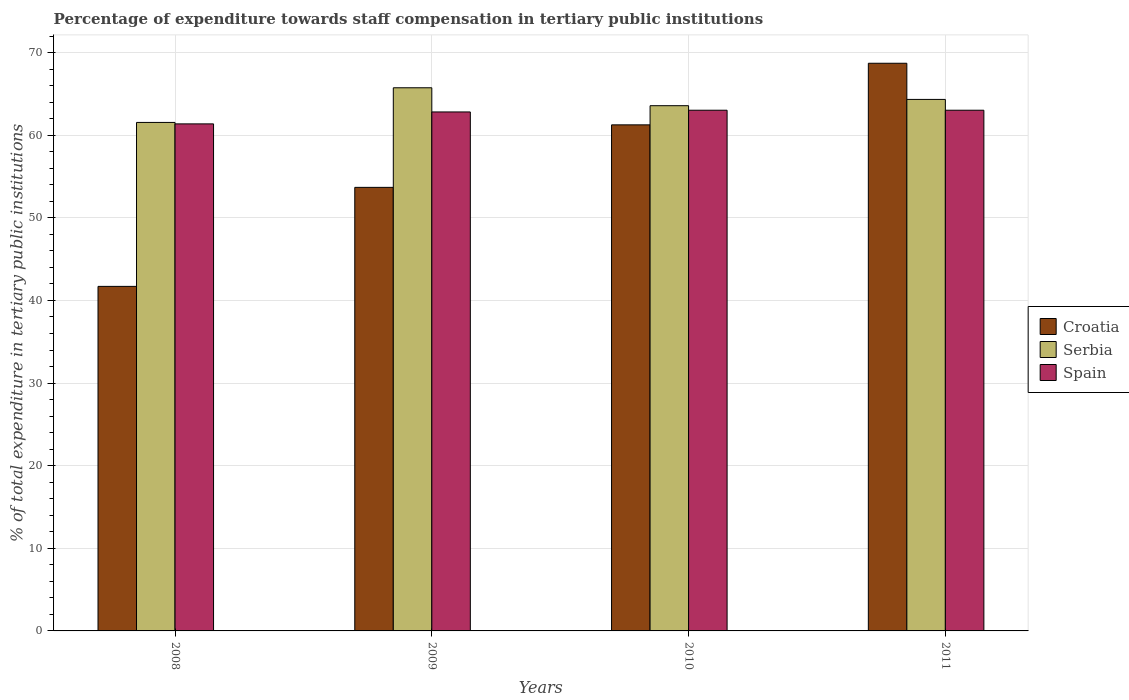Are the number of bars per tick equal to the number of legend labels?
Provide a succinct answer. Yes. Are the number of bars on each tick of the X-axis equal?
Offer a terse response. Yes. How many bars are there on the 1st tick from the left?
Make the answer very short. 3. How many bars are there on the 2nd tick from the right?
Make the answer very short. 3. What is the label of the 2nd group of bars from the left?
Offer a very short reply. 2009. In how many cases, is the number of bars for a given year not equal to the number of legend labels?
Provide a short and direct response. 0. What is the percentage of expenditure towards staff compensation in Spain in 2009?
Give a very brief answer. 62.82. Across all years, what is the maximum percentage of expenditure towards staff compensation in Croatia?
Keep it short and to the point. 68.71. Across all years, what is the minimum percentage of expenditure towards staff compensation in Serbia?
Ensure brevity in your answer.  61.55. In which year was the percentage of expenditure towards staff compensation in Spain maximum?
Provide a succinct answer. 2010. What is the total percentage of expenditure towards staff compensation in Serbia in the graph?
Ensure brevity in your answer.  255.2. What is the difference between the percentage of expenditure towards staff compensation in Serbia in 2008 and that in 2010?
Provide a succinct answer. -2.03. What is the difference between the percentage of expenditure towards staff compensation in Spain in 2011 and the percentage of expenditure towards staff compensation in Croatia in 2008?
Provide a succinct answer. 21.32. What is the average percentage of expenditure towards staff compensation in Serbia per year?
Provide a short and direct response. 63.8. In the year 2011, what is the difference between the percentage of expenditure towards staff compensation in Serbia and percentage of expenditure towards staff compensation in Croatia?
Offer a very short reply. -4.38. In how many years, is the percentage of expenditure towards staff compensation in Spain greater than 8 %?
Offer a very short reply. 4. What is the ratio of the percentage of expenditure towards staff compensation in Croatia in 2010 to that in 2011?
Offer a very short reply. 0.89. Is the percentage of expenditure towards staff compensation in Spain in 2008 less than that in 2010?
Keep it short and to the point. Yes. What is the difference between the highest and the lowest percentage of expenditure towards staff compensation in Spain?
Provide a succinct answer. 1.65. What does the 2nd bar from the right in 2008 represents?
Your answer should be very brief. Serbia. How many years are there in the graph?
Provide a succinct answer. 4. Does the graph contain any zero values?
Provide a short and direct response. No. Does the graph contain grids?
Offer a terse response. Yes. How are the legend labels stacked?
Offer a very short reply. Vertical. What is the title of the graph?
Your answer should be compact. Percentage of expenditure towards staff compensation in tertiary public institutions. What is the label or title of the X-axis?
Offer a very short reply. Years. What is the label or title of the Y-axis?
Give a very brief answer. % of total expenditure in tertiary public institutions. What is the % of total expenditure in tertiary public institutions of Croatia in 2008?
Your answer should be very brief. 41.7. What is the % of total expenditure in tertiary public institutions in Serbia in 2008?
Your response must be concise. 61.55. What is the % of total expenditure in tertiary public institutions of Spain in 2008?
Offer a very short reply. 61.37. What is the % of total expenditure in tertiary public institutions of Croatia in 2009?
Give a very brief answer. 53.69. What is the % of total expenditure in tertiary public institutions of Serbia in 2009?
Make the answer very short. 65.74. What is the % of total expenditure in tertiary public institutions in Spain in 2009?
Your answer should be compact. 62.82. What is the % of total expenditure in tertiary public institutions of Croatia in 2010?
Offer a very short reply. 61.25. What is the % of total expenditure in tertiary public institutions in Serbia in 2010?
Ensure brevity in your answer.  63.57. What is the % of total expenditure in tertiary public institutions of Spain in 2010?
Provide a short and direct response. 63.03. What is the % of total expenditure in tertiary public institutions of Croatia in 2011?
Your response must be concise. 68.71. What is the % of total expenditure in tertiary public institutions of Serbia in 2011?
Keep it short and to the point. 64.33. What is the % of total expenditure in tertiary public institutions of Spain in 2011?
Offer a very short reply. 63.03. Across all years, what is the maximum % of total expenditure in tertiary public institutions of Croatia?
Provide a short and direct response. 68.71. Across all years, what is the maximum % of total expenditure in tertiary public institutions in Serbia?
Your answer should be very brief. 65.74. Across all years, what is the maximum % of total expenditure in tertiary public institutions in Spain?
Provide a short and direct response. 63.03. Across all years, what is the minimum % of total expenditure in tertiary public institutions of Croatia?
Offer a terse response. 41.7. Across all years, what is the minimum % of total expenditure in tertiary public institutions of Serbia?
Your response must be concise. 61.55. Across all years, what is the minimum % of total expenditure in tertiary public institutions of Spain?
Your answer should be very brief. 61.37. What is the total % of total expenditure in tertiary public institutions in Croatia in the graph?
Make the answer very short. 225.35. What is the total % of total expenditure in tertiary public institutions of Serbia in the graph?
Offer a very short reply. 255.2. What is the total % of total expenditure in tertiary public institutions in Spain in the graph?
Your answer should be very brief. 250.24. What is the difference between the % of total expenditure in tertiary public institutions in Croatia in 2008 and that in 2009?
Your answer should be very brief. -11.98. What is the difference between the % of total expenditure in tertiary public institutions in Serbia in 2008 and that in 2009?
Provide a short and direct response. -4.19. What is the difference between the % of total expenditure in tertiary public institutions in Spain in 2008 and that in 2009?
Keep it short and to the point. -1.44. What is the difference between the % of total expenditure in tertiary public institutions in Croatia in 2008 and that in 2010?
Your answer should be very brief. -19.55. What is the difference between the % of total expenditure in tertiary public institutions of Serbia in 2008 and that in 2010?
Keep it short and to the point. -2.03. What is the difference between the % of total expenditure in tertiary public institutions of Spain in 2008 and that in 2010?
Your answer should be very brief. -1.65. What is the difference between the % of total expenditure in tertiary public institutions of Croatia in 2008 and that in 2011?
Give a very brief answer. -27.01. What is the difference between the % of total expenditure in tertiary public institutions in Serbia in 2008 and that in 2011?
Give a very brief answer. -2.79. What is the difference between the % of total expenditure in tertiary public institutions of Spain in 2008 and that in 2011?
Your answer should be very brief. -1.65. What is the difference between the % of total expenditure in tertiary public institutions in Croatia in 2009 and that in 2010?
Keep it short and to the point. -7.57. What is the difference between the % of total expenditure in tertiary public institutions in Serbia in 2009 and that in 2010?
Ensure brevity in your answer.  2.17. What is the difference between the % of total expenditure in tertiary public institutions of Spain in 2009 and that in 2010?
Make the answer very short. -0.21. What is the difference between the % of total expenditure in tertiary public institutions in Croatia in 2009 and that in 2011?
Offer a very short reply. -15.02. What is the difference between the % of total expenditure in tertiary public institutions in Serbia in 2009 and that in 2011?
Your response must be concise. 1.41. What is the difference between the % of total expenditure in tertiary public institutions of Spain in 2009 and that in 2011?
Give a very brief answer. -0.21. What is the difference between the % of total expenditure in tertiary public institutions of Croatia in 2010 and that in 2011?
Give a very brief answer. -7.46. What is the difference between the % of total expenditure in tertiary public institutions of Serbia in 2010 and that in 2011?
Your answer should be very brief. -0.76. What is the difference between the % of total expenditure in tertiary public institutions in Croatia in 2008 and the % of total expenditure in tertiary public institutions in Serbia in 2009?
Provide a short and direct response. -24.04. What is the difference between the % of total expenditure in tertiary public institutions in Croatia in 2008 and the % of total expenditure in tertiary public institutions in Spain in 2009?
Provide a succinct answer. -21.11. What is the difference between the % of total expenditure in tertiary public institutions of Serbia in 2008 and the % of total expenditure in tertiary public institutions of Spain in 2009?
Give a very brief answer. -1.27. What is the difference between the % of total expenditure in tertiary public institutions in Croatia in 2008 and the % of total expenditure in tertiary public institutions in Serbia in 2010?
Give a very brief answer. -21.87. What is the difference between the % of total expenditure in tertiary public institutions in Croatia in 2008 and the % of total expenditure in tertiary public institutions in Spain in 2010?
Make the answer very short. -21.32. What is the difference between the % of total expenditure in tertiary public institutions in Serbia in 2008 and the % of total expenditure in tertiary public institutions in Spain in 2010?
Your answer should be compact. -1.48. What is the difference between the % of total expenditure in tertiary public institutions of Croatia in 2008 and the % of total expenditure in tertiary public institutions of Serbia in 2011?
Offer a very short reply. -22.63. What is the difference between the % of total expenditure in tertiary public institutions in Croatia in 2008 and the % of total expenditure in tertiary public institutions in Spain in 2011?
Provide a succinct answer. -21.32. What is the difference between the % of total expenditure in tertiary public institutions in Serbia in 2008 and the % of total expenditure in tertiary public institutions in Spain in 2011?
Offer a terse response. -1.48. What is the difference between the % of total expenditure in tertiary public institutions of Croatia in 2009 and the % of total expenditure in tertiary public institutions of Serbia in 2010?
Your response must be concise. -9.89. What is the difference between the % of total expenditure in tertiary public institutions in Croatia in 2009 and the % of total expenditure in tertiary public institutions in Spain in 2010?
Ensure brevity in your answer.  -9.34. What is the difference between the % of total expenditure in tertiary public institutions in Serbia in 2009 and the % of total expenditure in tertiary public institutions in Spain in 2010?
Offer a terse response. 2.72. What is the difference between the % of total expenditure in tertiary public institutions of Croatia in 2009 and the % of total expenditure in tertiary public institutions of Serbia in 2011?
Provide a short and direct response. -10.65. What is the difference between the % of total expenditure in tertiary public institutions of Croatia in 2009 and the % of total expenditure in tertiary public institutions of Spain in 2011?
Provide a short and direct response. -9.34. What is the difference between the % of total expenditure in tertiary public institutions of Serbia in 2009 and the % of total expenditure in tertiary public institutions of Spain in 2011?
Your response must be concise. 2.72. What is the difference between the % of total expenditure in tertiary public institutions of Croatia in 2010 and the % of total expenditure in tertiary public institutions of Serbia in 2011?
Give a very brief answer. -3.08. What is the difference between the % of total expenditure in tertiary public institutions in Croatia in 2010 and the % of total expenditure in tertiary public institutions in Spain in 2011?
Your answer should be compact. -1.77. What is the difference between the % of total expenditure in tertiary public institutions of Serbia in 2010 and the % of total expenditure in tertiary public institutions of Spain in 2011?
Your response must be concise. 0.55. What is the average % of total expenditure in tertiary public institutions in Croatia per year?
Provide a succinct answer. 56.34. What is the average % of total expenditure in tertiary public institutions of Serbia per year?
Give a very brief answer. 63.8. What is the average % of total expenditure in tertiary public institutions in Spain per year?
Your answer should be compact. 62.56. In the year 2008, what is the difference between the % of total expenditure in tertiary public institutions of Croatia and % of total expenditure in tertiary public institutions of Serbia?
Give a very brief answer. -19.84. In the year 2008, what is the difference between the % of total expenditure in tertiary public institutions in Croatia and % of total expenditure in tertiary public institutions in Spain?
Make the answer very short. -19.67. In the year 2008, what is the difference between the % of total expenditure in tertiary public institutions of Serbia and % of total expenditure in tertiary public institutions of Spain?
Your answer should be very brief. 0.18. In the year 2009, what is the difference between the % of total expenditure in tertiary public institutions in Croatia and % of total expenditure in tertiary public institutions in Serbia?
Offer a very short reply. -12.06. In the year 2009, what is the difference between the % of total expenditure in tertiary public institutions in Croatia and % of total expenditure in tertiary public institutions in Spain?
Ensure brevity in your answer.  -9.13. In the year 2009, what is the difference between the % of total expenditure in tertiary public institutions of Serbia and % of total expenditure in tertiary public institutions of Spain?
Make the answer very short. 2.93. In the year 2010, what is the difference between the % of total expenditure in tertiary public institutions in Croatia and % of total expenditure in tertiary public institutions in Serbia?
Make the answer very short. -2.32. In the year 2010, what is the difference between the % of total expenditure in tertiary public institutions of Croatia and % of total expenditure in tertiary public institutions of Spain?
Make the answer very short. -1.77. In the year 2010, what is the difference between the % of total expenditure in tertiary public institutions of Serbia and % of total expenditure in tertiary public institutions of Spain?
Offer a terse response. 0.55. In the year 2011, what is the difference between the % of total expenditure in tertiary public institutions in Croatia and % of total expenditure in tertiary public institutions in Serbia?
Keep it short and to the point. 4.38. In the year 2011, what is the difference between the % of total expenditure in tertiary public institutions of Croatia and % of total expenditure in tertiary public institutions of Spain?
Your response must be concise. 5.68. In the year 2011, what is the difference between the % of total expenditure in tertiary public institutions in Serbia and % of total expenditure in tertiary public institutions in Spain?
Your response must be concise. 1.31. What is the ratio of the % of total expenditure in tertiary public institutions of Croatia in 2008 to that in 2009?
Offer a terse response. 0.78. What is the ratio of the % of total expenditure in tertiary public institutions in Serbia in 2008 to that in 2009?
Provide a short and direct response. 0.94. What is the ratio of the % of total expenditure in tertiary public institutions of Croatia in 2008 to that in 2010?
Your response must be concise. 0.68. What is the ratio of the % of total expenditure in tertiary public institutions in Serbia in 2008 to that in 2010?
Make the answer very short. 0.97. What is the ratio of the % of total expenditure in tertiary public institutions in Spain in 2008 to that in 2010?
Your answer should be very brief. 0.97. What is the ratio of the % of total expenditure in tertiary public institutions of Croatia in 2008 to that in 2011?
Give a very brief answer. 0.61. What is the ratio of the % of total expenditure in tertiary public institutions of Serbia in 2008 to that in 2011?
Your answer should be compact. 0.96. What is the ratio of the % of total expenditure in tertiary public institutions of Spain in 2008 to that in 2011?
Provide a succinct answer. 0.97. What is the ratio of the % of total expenditure in tertiary public institutions in Croatia in 2009 to that in 2010?
Provide a short and direct response. 0.88. What is the ratio of the % of total expenditure in tertiary public institutions in Serbia in 2009 to that in 2010?
Offer a very short reply. 1.03. What is the ratio of the % of total expenditure in tertiary public institutions of Spain in 2009 to that in 2010?
Your answer should be very brief. 1. What is the ratio of the % of total expenditure in tertiary public institutions of Croatia in 2009 to that in 2011?
Give a very brief answer. 0.78. What is the ratio of the % of total expenditure in tertiary public institutions of Serbia in 2009 to that in 2011?
Provide a succinct answer. 1.02. What is the ratio of the % of total expenditure in tertiary public institutions of Spain in 2009 to that in 2011?
Your answer should be very brief. 1. What is the ratio of the % of total expenditure in tertiary public institutions of Croatia in 2010 to that in 2011?
Ensure brevity in your answer.  0.89. What is the difference between the highest and the second highest % of total expenditure in tertiary public institutions in Croatia?
Ensure brevity in your answer.  7.46. What is the difference between the highest and the second highest % of total expenditure in tertiary public institutions in Serbia?
Offer a very short reply. 1.41. What is the difference between the highest and the second highest % of total expenditure in tertiary public institutions of Spain?
Your response must be concise. 0. What is the difference between the highest and the lowest % of total expenditure in tertiary public institutions in Croatia?
Your answer should be compact. 27.01. What is the difference between the highest and the lowest % of total expenditure in tertiary public institutions of Serbia?
Provide a short and direct response. 4.19. What is the difference between the highest and the lowest % of total expenditure in tertiary public institutions of Spain?
Your answer should be compact. 1.65. 